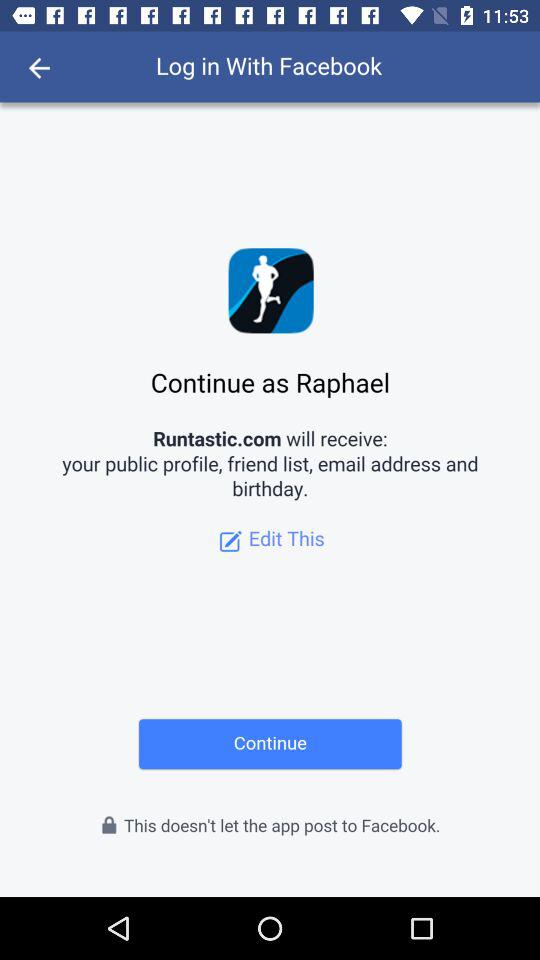What application is asking for permission? The application is "Runtastic.com". 